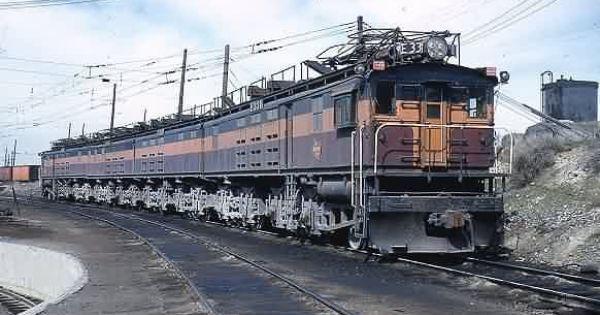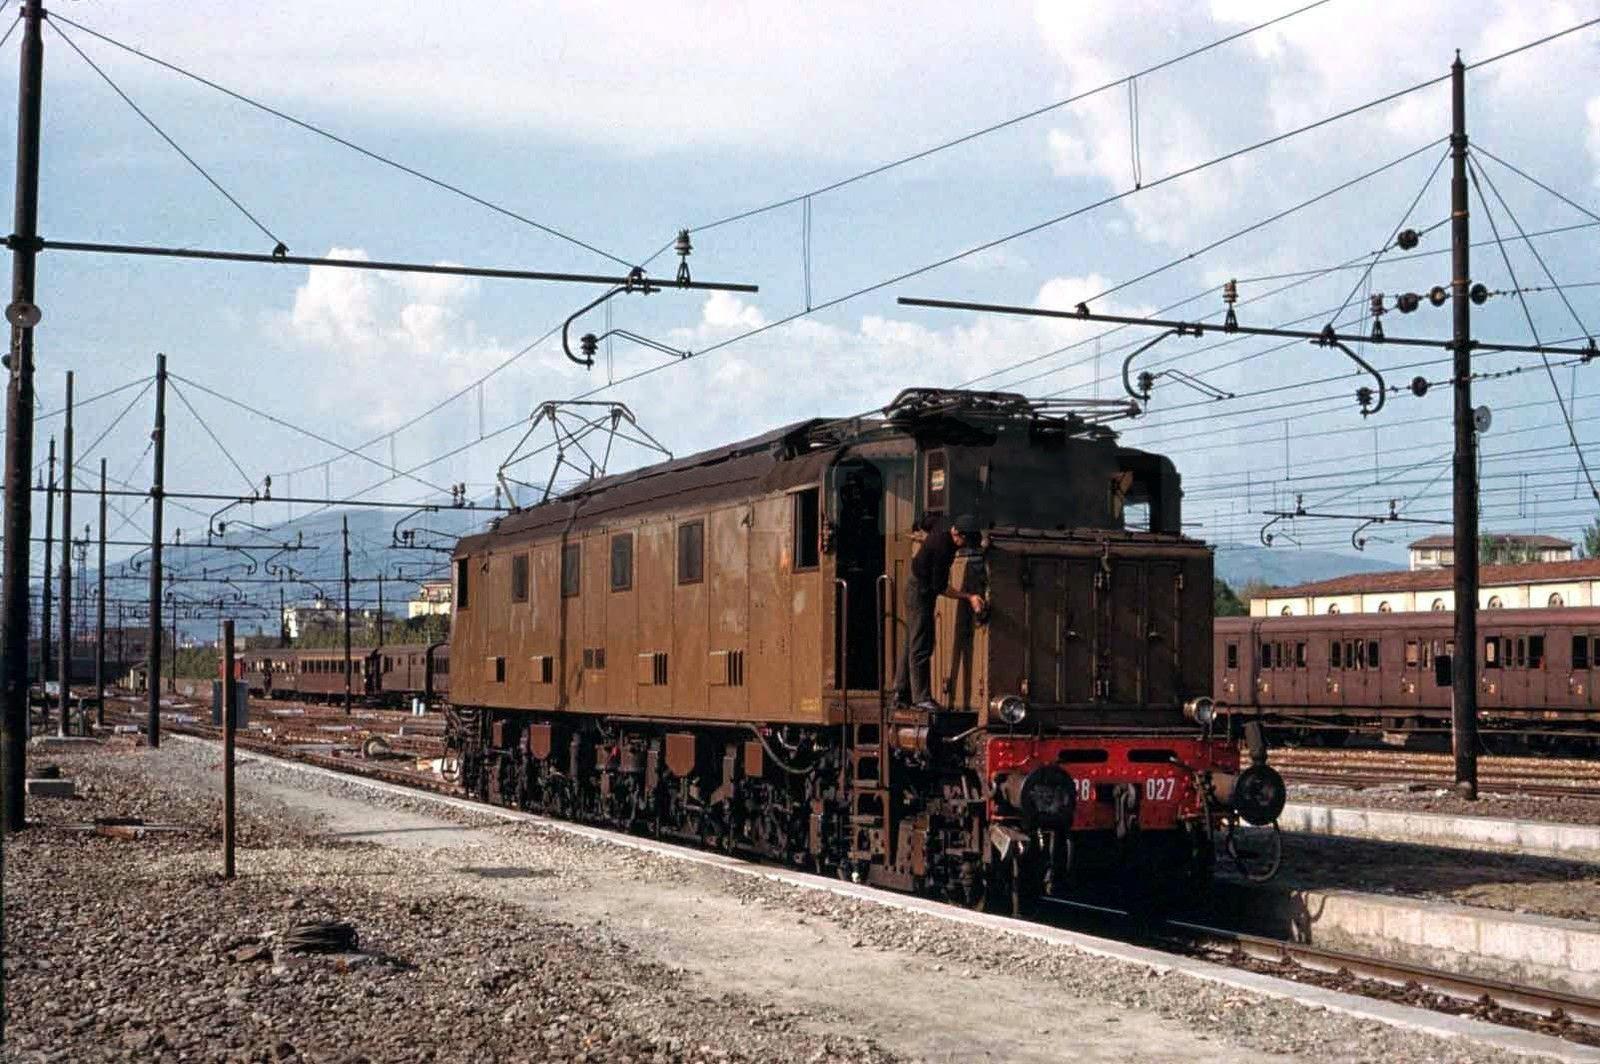The first image is the image on the left, the second image is the image on the right. Evaluate the accuracy of this statement regarding the images: "At least one of the trains is painted with the bottom half orange, and the top half brown.". Is it true? Answer yes or no. No. The first image is the image on the left, the second image is the image on the right. Considering the images on both sides, is "The train in the right image has a slightly pitched top like a peaked roof and has at least two distinct colors that run its length." valid? Answer yes or no. No. 